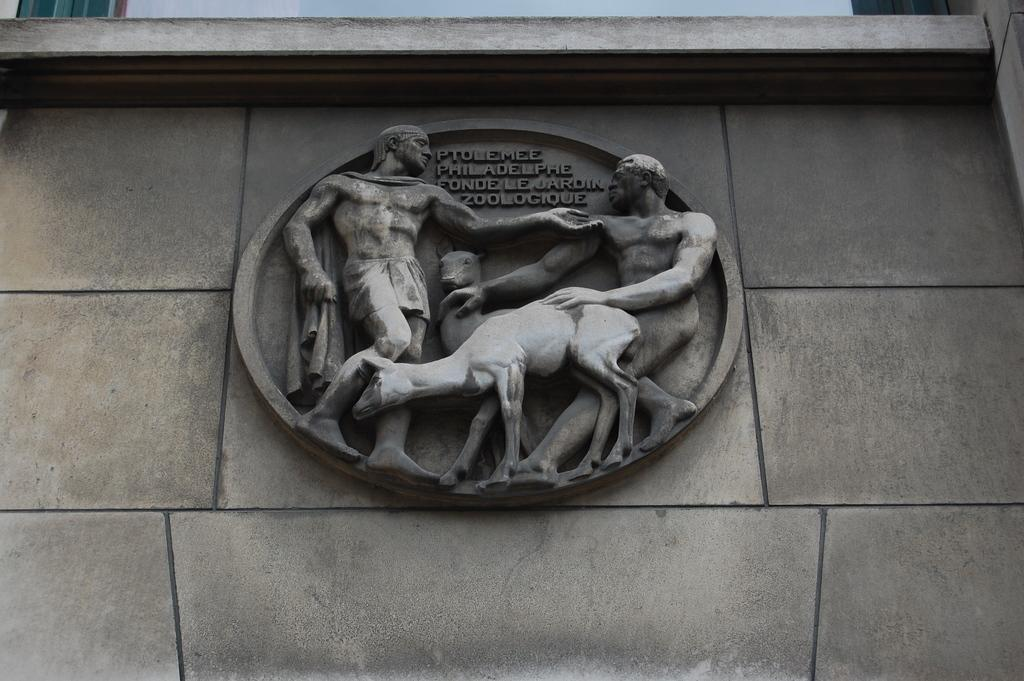What type of art can be seen in the image? There are sculptures in the image. What else can be seen on the walls in the image? There are texts written on a wall in the image. What architectural features are visible in the image? There are walls visible at the top of the image. What is visible in the sky in the image? Clouds are present in the sky in the image. Can you see the steam coming out of the sculpture's face in the image? There is no steam or face present in the image; it features sculptures and texts on a wall. 